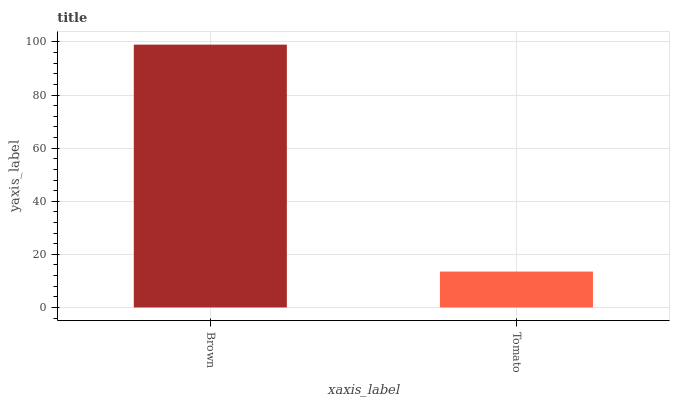Is Tomato the minimum?
Answer yes or no. Yes. Is Brown the maximum?
Answer yes or no. Yes. Is Tomato the maximum?
Answer yes or no. No. Is Brown greater than Tomato?
Answer yes or no. Yes. Is Tomato less than Brown?
Answer yes or no. Yes. Is Tomato greater than Brown?
Answer yes or no. No. Is Brown less than Tomato?
Answer yes or no. No. Is Brown the high median?
Answer yes or no. Yes. Is Tomato the low median?
Answer yes or no. Yes. Is Tomato the high median?
Answer yes or no. No. Is Brown the low median?
Answer yes or no. No. 